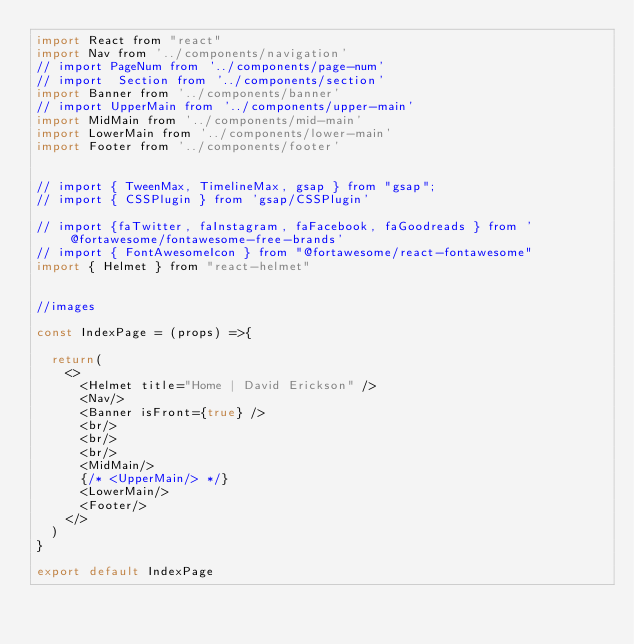Convert code to text. <code><loc_0><loc_0><loc_500><loc_500><_JavaScript_>import React from "react"
import Nav from '../components/navigation'
// import PageNum from '../components/page-num'
// import  Section from '../components/section'
import Banner from '../components/banner'
// import UpperMain from '../components/upper-main'
import MidMain from '../components/mid-main'
import LowerMain from '../components/lower-main'
import Footer from '../components/footer'


// import { TweenMax, TimelineMax, gsap } from "gsap";
// import { CSSPlugin } from 'gsap/CSSPlugin'

// import {faTwitter, faInstagram, faFacebook, faGoodreads } from '@fortawesome/fontawesome-free-brands'
// import { FontAwesomeIcon } from "@fortawesome/react-fontawesome"
import { Helmet } from "react-helmet"


//images

const IndexPage = (props) =>{

  return(
    <>
      <Helmet title="Home | David Erickson" />
      <Nav/>
      <Banner isFront={true} />
      <br/>
      <br/>
      <br/>
      <MidMain/>
      {/* <UpperMain/> */}
      <LowerMain/>
      <Footer/>
    </>
  )
}

export default IndexPage
</code> 